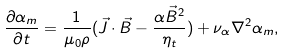Convert formula to latex. <formula><loc_0><loc_0><loc_500><loc_500>\frac { \partial \alpha _ { m } } { \partial t } = \frac { 1 } { \mu _ { 0 } \rho } ( \vec { J } \cdot \vec { B } - \frac { \alpha \vec { B } ^ { 2 } } { \eta _ { t } } ) + \nu _ { \alpha } \nabla ^ { 2 } \alpha _ { m } ,</formula> 